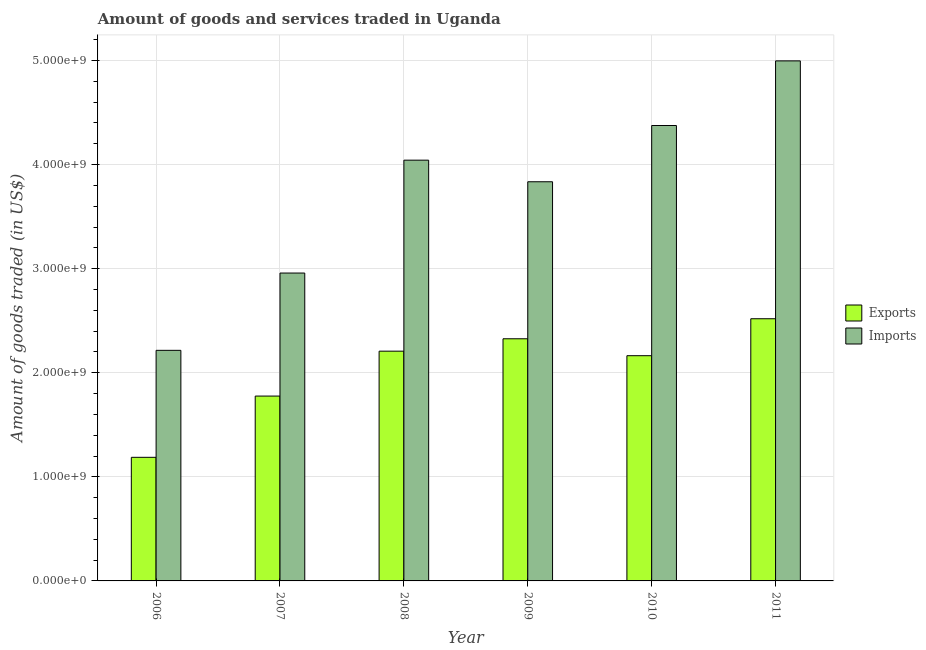How many groups of bars are there?
Ensure brevity in your answer.  6. Are the number of bars on each tick of the X-axis equal?
Make the answer very short. Yes. In how many cases, is the number of bars for a given year not equal to the number of legend labels?
Provide a succinct answer. 0. What is the amount of goods exported in 2007?
Keep it short and to the point. 1.78e+09. Across all years, what is the maximum amount of goods exported?
Provide a short and direct response. 2.52e+09. Across all years, what is the minimum amount of goods exported?
Keep it short and to the point. 1.19e+09. In which year was the amount of goods imported maximum?
Make the answer very short. 2011. In which year was the amount of goods exported minimum?
Your answer should be compact. 2006. What is the total amount of goods exported in the graph?
Ensure brevity in your answer.  1.22e+1. What is the difference between the amount of goods imported in 2008 and that in 2011?
Provide a succinct answer. -9.54e+08. What is the difference between the amount of goods imported in 2008 and the amount of goods exported in 2007?
Ensure brevity in your answer.  1.08e+09. What is the average amount of goods imported per year?
Your answer should be very brief. 3.74e+09. In the year 2008, what is the difference between the amount of goods exported and amount of goods imported?
Your answer should be compact. 0. What is the ratio of the amount of goods imported in 2006 to that in 2010?
Give a very brief answer. 0.51. Is the amount of goods imported in 2006 less than that in 2009?
Keep it short and to the point. Yes. What is the difference between the highest and the second highest amount of goods exported?
Your answer should be compact. 1.93e+08. What is the difference between the highest and the lowest amount of goods imported?
Provide a short and direct response. 2.78e+09. In how many years, is the amount of goods exported greater than the average amount of goods exported taken over all years?
Your answer should be very brief. 4. Is the sum of the amount of goods exported in 2009 and 2011 greater than the maximum amount of goods imported across all years?
Provide a succinct answer. Yes. What does the 2nd bar from the left in 2008 represents?
Your answer should be very brief. Imports. What does the 1st bar from the right in 2008 represents?
Give a very brief answer. Imports. How many years are there in the graph?
Ensure brevity in your answer.  6. Are the values on the major ticks of Y-axis written in scientific E-notation?
Make the answer very short. Yes. Does the graph contain any zero values?
Give a very brief answer. No. How many legend labels are there?
Keep it short and to the point. 2. What is the title of the graph?
Offer a very short reply. Amount of goods and services traded in Uganda. Does "Investment in Transport" appear as one of the legend labels in the graph?
Your response must be concise. No. What is the label or title of the Y-axis?
Make the answer very short. Amount of goods traded (in US$). What is the Amount of goods traded (in US$) of Exports in 2006?
Give a very brief answer. 1.19e+09. What is the Amount of goods traded (in US$) in Imports in 2006?
Make the answer very short. 2.22e+09. What is the Amount of goods traded (in US$) of Exports in 2007?
Your answer should be very brief. 1.78e+09. What is the Amount of goods traded (in US$) of Imports in 2007?
Ensure brevity in your answer.  2.96e+09. What is the Amount of goods traded (in US$) in Exports in 2008?
Make the answer very short. 2.21e+09. What is the Amount of goods traded (in US$) of Imports in 2008?
Keep it short and to the point. 4.04e+09. What is the Amount of goods traded (in US$) of Exports in 2009?
Provide a succinct answer. 2.33e+09. What is the Amount of goods traded (in US$) in Imports in 2009?
Offer a terse response. 3.84e+09. What is the Amount of goods traded (in US$) in Exports in 2010?
Offer a terse response. 2.16e+09. What is the Amount of goods traded (in US$) of Imports in 2010?
Provide a succinct answer. 4.38e+09. What is the Amount of goods traded (in US$) of Exports in 2011?
Ensure brevity in your answer.  2.52e+09. What is the Amount of goods traded (in US$) of Imports in 2011?
Ensure brevity in your answer.  5.00e+09. Across all years, what is the maximum Amount of goods traded (in US$) in Exports?
Your response must be concise. 2.52e+09. Across all years, what is the maximum Amount of goods traded (in US$) in Imports?
Keep it short and to the point. 5.00e+09. Across all years, what is the minimum Amount of goods traded (in US$) in Exports?
Make the answer very short. 1.19e+09. Across all years, what is the minimum Amount of goods traded (in US$) of Imports?
Provide a short and direct response. 2.22e+09. What is the total Amount of goods traded (in US$) of Exports in the graph?
Your answer should be very brief. 1.22e+1. What is the total Amount of goods traded (in US$) of Imports in the graph?
Your response must be concise. 2.24e+1. What is the difference between the Amount of goods traded (in US$) of Exports in 2006 and that in 2007?
Make the answer very short. -5.89e+08. What is the difference between the Amount of goods traded (in US$) in Imports in 2006 and that in 2007?
Ensure brevity in your answer.  -7.43e+08. What is the difference between the Amount of goods traded (in US$) in Exports in 2006 and that in 2008?
Give a very brief answer. -1.02e+09. What is the difference between the Amount of goods traded (in US$) of Imports in 2006 and that in 2008?
Offer a terse response. -1.83e+09. What is the difference between the Amount of goods traded (in US$) of Exports in 2006 and that in 2009?
Offer a very short reply. -1.14e+09. What is the difference between the Amount of goods traded (in US$) in Imports in 2006 and that in 2009?
Your answer should be compact. -1.62e+09. What is the difference between the Amount of goods traded (in US$) in Exports in 2006 and that in 2010?
Offer a very short reply. -9.76e+08. What is the difference between the Amount of goods traded (in US$) of Imports in 2006 and that in 2010?
Ensure brevity in your answer.  -2.16e+09. What is the difference between the Amount of goods traded (in US$) in Exports in 2006 and that in 2011?
Provide a short and direct response. -1.33e+09. What is the difference between the Amount of goods traded (in US$) of Imports in 2006 and that in 2011?
Make the answer very short. -2.78e+09. What is the difference between the Amount of goods traded (in US$) of Exports in 2007 and that in 2008?
Ensure brevity in your answer.  -4.31e+08. What is the difference between the Amount of goods traded (in US$) of Imports in 2007 and that in 2008?
Keep it short and to the point. -1.08e+09. What is the difference between the Amount of goods traded (in US$) of Exports in 2007 and that in 2009?
Offer a very short reply. -5.50e+08. What is the difference between the Amount of goods traded (in US$) of Imports in 2007 and that in 2009?
Make the answer very short. -8.77e+08. What is the difference between the Amount of goods traded (in US$) in Exports in 2007 and that in 2010?
Your response must be concise. -3.88e+08. What is the difference between the Amount of goods traded (in US$) of Imports in 2007 and that in 2010?
Provide a succinct answer. -1.42e+09. What is the difference between the Amount of goods traded (in US$) of Exports in 2007 and that in 2011?
Your response must be concise. -7.43e+08. What is the difference between the Amount of goods traded (in US$) in Imports in 2007 and that in 2011?
Your answer should be very brief. -2.04e+09. What is the difference between the Amount of goods traded (in US$) in Exports in 2008 and that in 2009?
Offer a very short reply. -1.19e+08. What is the difference between the Amount of goods traded (in US$) of Imports in 2008 and that in 2009?
Ensure brevity in your answer.  2.08e+08. What is the difference between the Amount of goods traded (in US$) in Exports in 2008 and that in 2010?
Your response must be concise. 4.37e+07. What is the difference between the Amount of goods traded (in US$) in Imports in 2008 and that in 2010?
Ensure brevity in your answer.  -3.33e+08. What is the difference between the Amount of goods traded (in US$) in Exports in 2008 and that in 2011?
Offer a very short reply. -3.11e+08. What is the difference between the Amount of goods traded (in US$) in Imports in 2008 and that in 2011?
Keep it short and to the point. -9.54e+08. What is the difference between the Amount of goods traded (in US$) in Exports in 2009 and that in 2010?
Offer a very short reply. 1.63e+08. What is the difference between the Amount of goods traded (in US$) of Imports in 2009 and that in 2010?
Give a very brief answer. -5.40e+08. What is the difference between the Amount of goods traded (in US$) in Exports in 2009 and that in 2011?
Give a very brief answer. -1.93e+08. What is the difference between the Amount of goods traded (in US$) of Imports in 2009 and that in 2011?
Give a very brief answer. -1.16e+09. What is the difference between the Amount of goods traded (in US$) in Exports in 2010 and that in 2011?
Your answer should be compact. -3.55e+08. What is the difference between the Amount of goods traded (in US$) of Imports in 2010 and that in 2011?
Ensure brevity in your answer.  -6.21e+08. What is the difference between the Amount of goods traded (in US$) of Exports in 2006 and the Amount of goods traded (in US$) of Imports in 2007?
Offer a very short reply. -1.77e+09. What is the difference between the Amount of goods traded (in US$) of Exports in 2006 and the Amount of goods traded (in US$) of Imports in 2008?
Offer a very short reply. -2.86e+09. What is the difference between the Amount of goods traded (in US$) of Exports in 2006 and the Amount of goods traded (in US$) of Imports in 2009?
Provide a short and direct response. -2.65e+09. What is the difference between the Amount of goods traded (in US$) of Exports in 2006 and the Amount of goods traded (in US$) of Imports in 2010?
Offer a terse response. -3.19e+09. What is the difference between the Amount of goods traded (in US$) in Exports in 2006 and the Amount of goods traded (in US$) in Imports in 2011?
Your answer should be very brief. -3.81e+09. What is the difference between the Amount of goods traded (in US$) in Exports in 2007 and the Amount of goods traded (in US$) in Imports in 2008?
Make the answer very short. -2.27e+09. What is the difference between the Amount of goods traded (in US$) of Exports in 2007 and the Amount of goods traded (in US$) of Imports in 2009?
Provide a short and direct response. -2.06e+09. What is the difference between the Amount of goods traded (in US$) of Exports in 2007 and the Amount of goods traded (in US$) of Imports in 2010?
Your response must be concise. -2.60e+09. What is the difference between the Amount of goods traded (in US$) in Exports in 2007 and the Amount of goods traded (in US$) in Imports in 2011?
Give a very brief answer. -3.22e+09. What is the difference between the Amount of goods traded (in US$) of Exports in 2008 and the Amount of goods traded (in US$) of Imports in 2009?
Provide a short and direct response. -1.63e+09. What is the difference between the Amount of goods traded (in US$) in Exports in 2008 and the Amount of goods traded (in US$) in Imports in 2010?
Provide a short and direct response. -2.17e+09. What is the difference between the Amount of goods traded (in US$) in Exports in 2008 and the Amount of goods traded (in US$) in Imports in 2011?
Your answer should be compact. -2.79e+09. What is the difference between the Amount of goods traded (in US$) of Exports in 2009 and the Amount of goods traded (in US$) of Imports in 2010?
Ensure brevity in your answer.  -2.05e+09. What is the difference between the Amount of goods traded (in US$) of Exports in 2009 and the Amount of goods traded (in US$) of Imports in 2011?
Offer a terse response. -2.67e+09. What is the difference between the Amount of goods traded (in US$) in Exports in 2010 and the Amount of goods traded (in US$) in Imports in 2011?
Offer a very short reply. -2.83e+09. What is the average Amount of goods traded (in US$) in Exports per year?
Provide a short and direct response. 2.03e+09. What is the average Amount of goods traded (in US$) of Imports per year?
Ensure brevity in your answer.  3.74e+09. In the year 2006, what is the difference between the Amount of goods traded (in US$) of Exports and Amount of goods traded (in US$) of Imports?
Your answer should be compact. -1.03e+09. In the year 2007, what is the difference between the Amount of goods traded (in US$) of Exports and Amount of goods traded (in US$) of Imports?
Your response must be concise. -1.18e+09. In the year 2008, what is the difference between the Amount of goods traded (in US$) of Exports and Amount of goods traded (in US$) of Imports?
Keep it short and to the point. -1.84e+09. In the year 2009, what is the difference between the Amount of goods traded (in US$) in Exports and Amount of goods traded (in US$) in Imports?
Your answer should be very brief. -1.51e+09. In the year 2010, what is the difference between the Amount of goods traded (in US$) of Exports and Amount of goods traded (in US$) of Imports?
Your answer should be compact. -2.21e+09. In the year 2011, what is the difference between the Amount of goods traded (in US$) in Exports and Amount of goods traded (in US$) in Imports?
Your answer should be compact. -2.48e+09. What is the ratio of the Amount of goods traded (in US$) in Exports in 2006 to that in 2007?
Offer a very short reply. 0.67. What is the ratio of the Amount of goods traded (in US$) in Imports in 2006 to that in 2007?
Give a very brief answer. 0.75. What is the ratio of the Amount of goods traded (in US$) in Exports in 2006 to that in 2008?
Provide a short and direct response. 0.54. What is the ratio of the Amount of goods traded (in US$) of Imports in 2006 to that in 2008?
Make the answer very short. 0.55. What is the ratio of the Amount of goods traded (in US$) in Exports in 2006 to that in 2009?
Give a very brief answer. 0.51. What is the ratio of the Amount of goods traded (in US$) of Imports in 2006 to that in 2009?
Your answer should be very brief. 0.58. What is the ratio of the Amount of goods traded (in US$) of Exports in 2006 to that in 2010?
Offer a terse response. 0.55. What is the ratio of the Amount of goods traded (in US$) in Imports in 2006 to that in 2010?
Ensure brevity in your answer.  0.51. What is the ratio of the Amount of goods traded (in US$) in Exports in 2006 to that in 2011?
Keep it short and to the point. 0.47. What is the ratio of the Amount of goods traded (in US$) in Imports in 2006 to that in 2011?
Your response must be concise. 0.44. What is the ratio of the Amount of goods traded (in US$) in Exports in 2007 to that in 2008?
Your answer should be very brief. 0.8. What is the ratio of the Amount of goods traded (in US$) of Imports in 2007 to that in 2008?
Provide a succinct answer. 0.73. What is the ratio of the Amount of goods traded (in US$) in Exports in 2007 to that in 2009?
Your response must be concise. 0.76. What is the ratio of the Amount of goods traded (in US$) in Imports in 2007 to that in 2009?
Make the answer very short. 0.77. What is the ratio of the Amount of goods traded (in US$) in Exports in 2007 to that in 2010?
Provide a succinct answer. 0.82. What is the ratio of the Amount of goods traded (in US$) of Imports in 2007 to that in 2010?
Offer a very short reply. 0.68. What is the ratio of the Amount of goods traded (in US$) in Exports in 2007 to that in 2011?
Ensure brevity in your answer.  0.71. What is the ratio of the Amount of goods traded (in US$) of Imports in 2007 to that in 2011?
Provide a short and direct response. 0.59. What is the ratio of the Amount of goods traded (in US$) of Exports in 2008 to that in 2009?
Give a very brief answer. 0.95. What is the ratio of the Amount of goods traded (in US$) in Imports in 2008 to that in 2009?
Ensure brevity in your answer.  1.05. What is the ratio of the Amount of goods traded (in US$) of Exports in 2008 to that in 2010?
Offer a terse response. 1.02. What is the ratio of the Amount of goods traded (in US$) of Imports in 2008 to that in 2010?
Provide a succinct answer. 0.92. What is the ratio of the Amount of goods traded (in US$) of Exports in 2008 to that in 2011?
Offer a terse response. 0.88. What is the ratio of the Amount of goods traded (in US$) in Imports in 2008 to that in 2011?
Offer a very short reply. 0.81. What is the ratio of the Amount of goods traded (in US$) of Exports in 2009 to that in 2010?
Ensure brevity in your answer.  1.08. What is the ratio of the Amount of goods traded (in US$) in Imports in 2009 to that in 2010?
Your response must be concise. 0.88. What is the ratio of the Amount of goods traded (in US$) in Exports in 2009 to that in 2011?
Give a very brief answer. 0.92. What is the ratio of the Amount of goods traded (in US$) in Imports in 2009 to that in 2011?
Ensure brevity in your answer.  0.77. What is the ratio of the Amount of goods traded (in US$) in Exports in 2010 to that in 2011?
Provide a succinct answer. 0.86. What is the ratio of the Amount of goods traded (in US$) in Imports in 2010 to that in 2011?
Make the answer very short. 0.88. What is the difference between the highest and the second highest Amount of goods traded (in US$) in Exports?
Provide a succinct answer. 1.93e+08. What is the difference between the highest and the second highest Amount of goods traded (in US$) of Imports?
Provide a short and direct response. 6.21e+08. What is the difference between the highest and the lowest Amount of goods traded (in US$) in Exports?
Give a very brief answer. 1.33e+09. What is the difference between the highest and the lowest Amount of goods traded (in US$) in Imports?
Ensure brevity in your answer.  2.78e+09. 